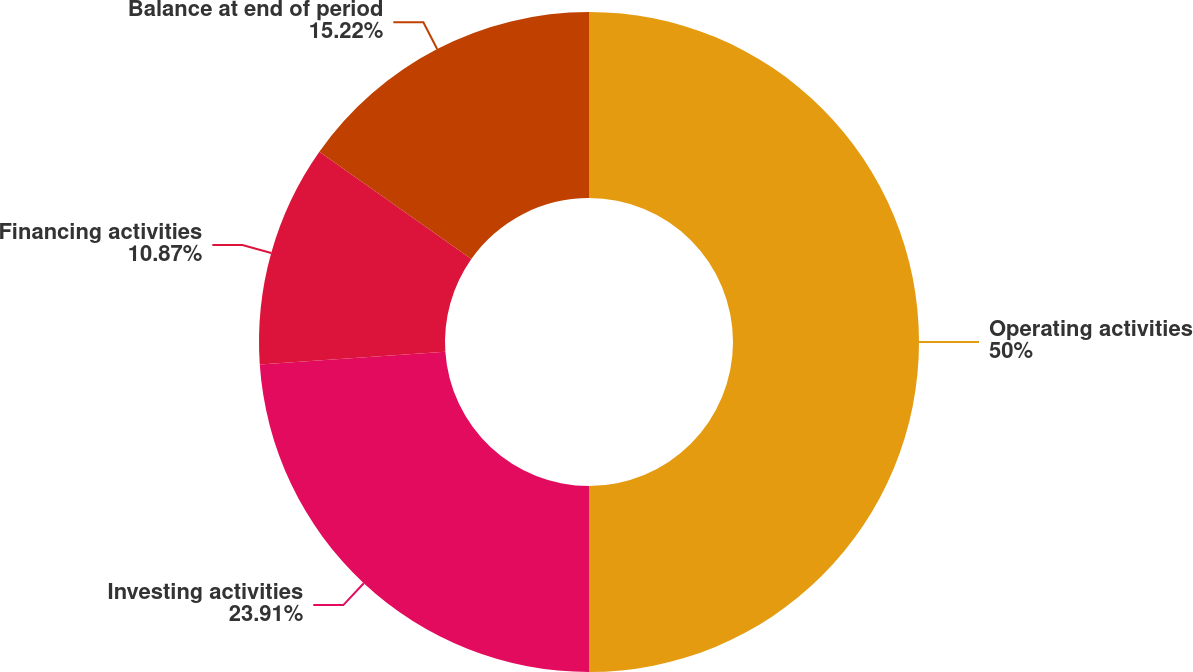Convert chart. <chart><loc_0><loc_0><loc_500><loc_500><pie_chart><fcel>Operating activities<fcel>Investing activities<fcel>Financing activities<fcel>Balance at end of period<nl><fcel>50.0%<fcel>23.91%<fcel>10.87%<fcel>15.22%<nl></chart> 